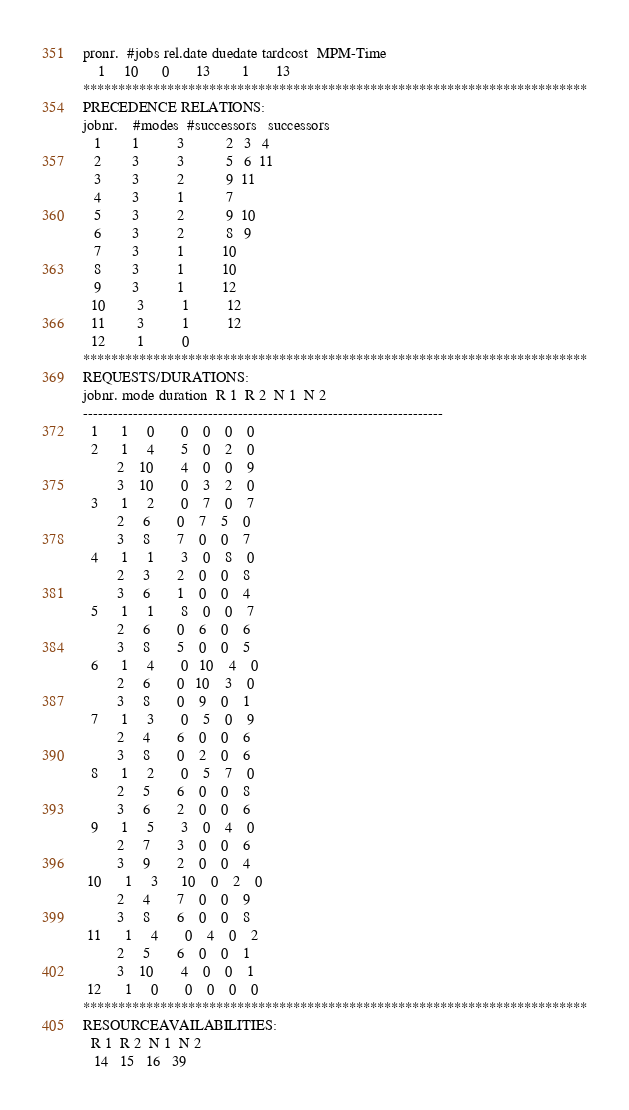<code> <loc_0><loc_0><loc_500><loc_500><_ObjectiveC_>pronr.  #jobs rel.date duedate tardcost  MPM-Time
    1     10      0       13        1       13
************************************************************************
PRECEDENCE RELATIONS:
jobnr.    #modes  #successors   successors
   1        1          3           2   3   4
   2        3          3           5   6  11
   3        3          2           9  11
   4        3          1           7
   5        3          2           9  10
   6        3          2           8   9
   7        3          1          10
   8        3          1          10
   9        3          1          12
  10        3          1          12
  11        3          1          12
  12        1          0        
************************************************************************
REQUESTS/DURATIONS:
jobnr. mode duration  R 1  R 2  N 1  N 2
------------------------------------------------------------------------
  1      1     0       0    0    0    0
  2      1     4       5    0    2    0
         2    10       4    0    0    9
         3    10       0    3    2    0
  3      1     2       0    7    0    7
         2     6       0    7    5    0
         3     8       7    0    0    7
  4      1     1       3    0    8    0
         2     3       2    0    0    8
         3     6       1    0    0    4
  5      1     1       8    0    0    7
         2     6       0    6    0    6
         3     8       5    0    0    5
  6      1     4       0   10    4    0
         2     6       0   10    3    0
         3     8       0    9    0    1
  7      1     3       0    5    0    9
         2     4       6    0    0    6
         3     8       0    2    0    6
  8      1     2       0    5    7    0
         2     5       6    0    0    8
         3     6       2    0    0    6
  9      1     5       3    0    4    0
         2     7       3    0    0    6
         3     9       2    0    0    4
 10      1     3      10    0    2    0
         2     4       7    0    0    9
         3     8       6    0    0    8
 11      1     4       0    4    0    2
         2     5       6    0    0    1
         3    10       4    0    0    1
 12      1     0       0    0    0    0
************************************************************************
RESOURCEAVAILABILITIES:
  R 1  R 2  N 1  N 2
   14   15   16   39</code> 